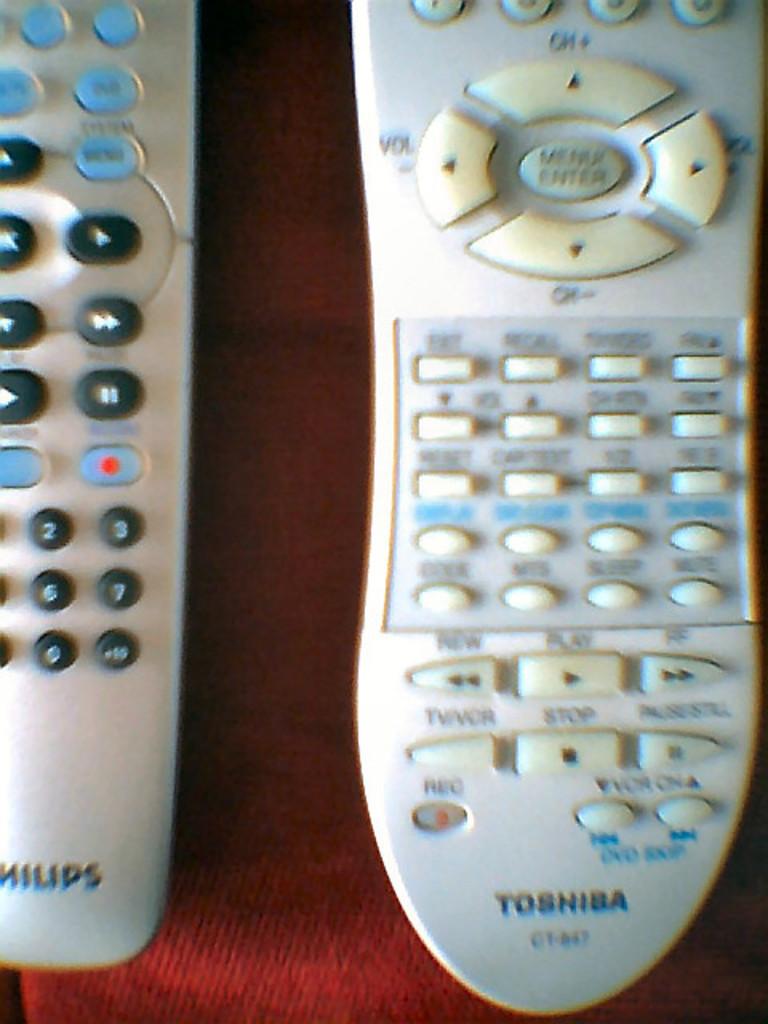Who makes the right remote control?
Provide a succinct answer. Toshiba. What is one of the letters found on the left remote?
Provide a succinct answer. S. 